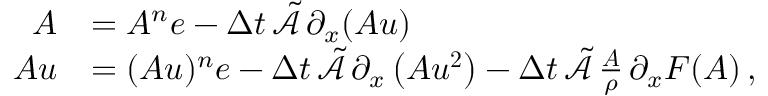<formula> <loc_0><loc_0><loc_500><loc_500>\begin{array} { r l } { A } & { = A ^ { n } e - \Delta t \, \tilde { \mathcal { A } } \, \partial _ { x } ( A u ) } \\ { A u } & { = ( A u ) ^ { n } e - \Delta t \, \tilde { \mathcal { A } } \, \partial _ { x } \left ( A u ^ { 2 } \right ) - \Delta t \, \tilde { \mathcal { A } } \, \frac { A } { \rho } \, \partial _ { x } F ( A ) \, , } \end{array}</formula> 